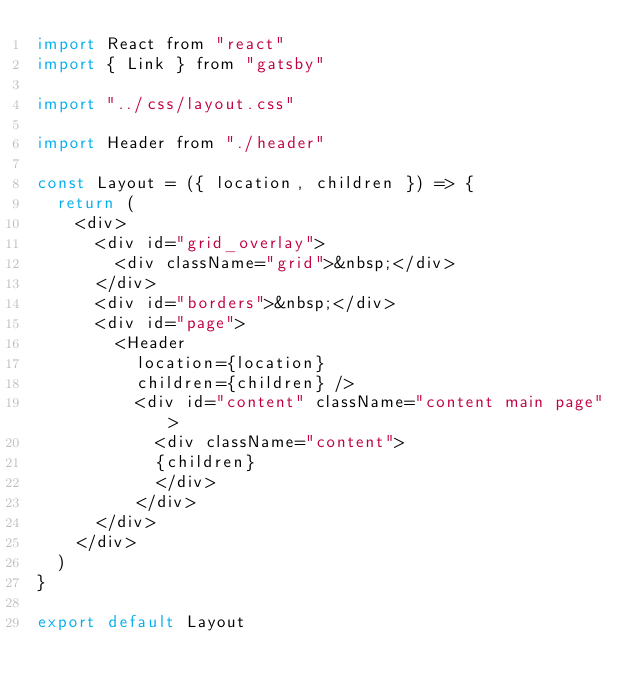<code> <loc_0><loc_0><loc_500><loc_500><_JavaScript_>import React from "react"
import { Link } from "gatsby"

import "../css/layout.css"

import Header from "./header"

const Layout = ({ location, children }) => {
  return (
    <div>
      <div id="grid_overlay">
        <div className="grid">&nbsp;</div>
      </div>
      <div id="borders">&nbsp;</div>
      <div id="page">
        <Header
          location={location}
          children={children} />
          <div id="content" className="content main page">
            <div className="content">
            {children}
            </div>
          </div>
      </div>
    </div>
  )
}

export default Layout
</code> 